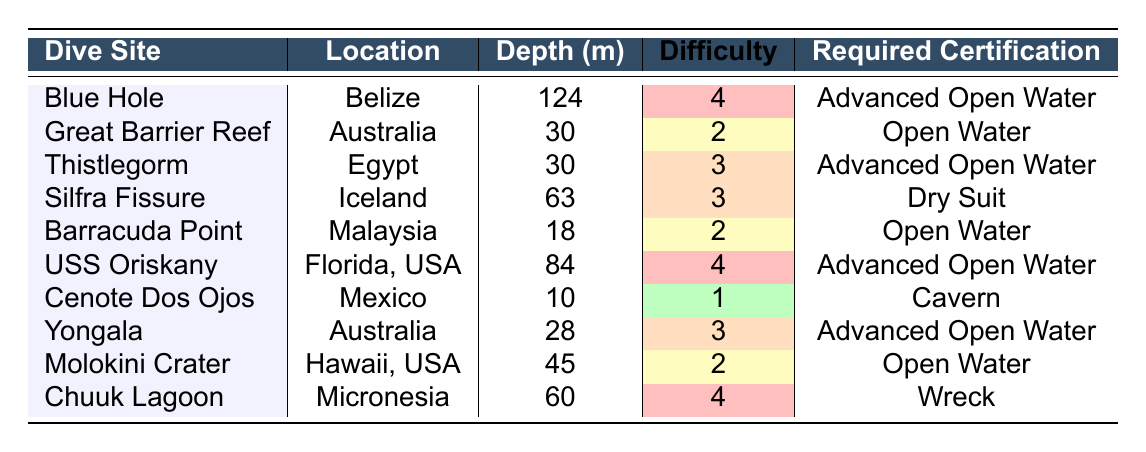What is the depth of the Blue Hole dive site? The table lists the depth for each dive site. For the Blue Hole, the depth is explicitly stated as 124 meters.
Answer: 124 meters How many dive sites require Advanced Open Water certification? By examining the required certifications column, I can count the instances of "Advanced Open Water". There are three sites listed: Blue Hole, Thistlegorm, and USS Oriskany, Yongala also requires the same certification, making a total of four.
Answer: 4 Which dive site has the highest difficulty rating? The difficulty ratings for all dive sites are provided. The maximum rating is 4, which is associated with Blue Hole, USS Oriskany, and Chuuk Lagoon. Since we are looking for the highest, it's Blue Hole.
Answer: Blue Hole What is the average depth of the dive sites listed? We need to sum the depths of all the dive sites: 124 + 30 + 30 + 63 + 18 + 84 + 10 + 28 + 45 + 60 =  460 meters. There are 10 sites, so the average depth is 460/10 = 46 meters.
Answer: 46 meters Is there a dive site that is suitable for beginners? A beginner-friendly dive site typically requires an Open Water certification. Looking at the table, both the Great Barrier Reef and Barracuda Point require Open Water certification. Thus, the answer is yes.
Answer: Yes Which dive site in the table is located in Australia and what is its depth? The table shows two dive sites located in Australia: Great Barrier Reef (depth 30 m) and Yongala (depth 28 m). Both depths are mentioned.
Answer: Great Barrier Reef (30 m), Yongala (28 m) What is the total depth of all dive sites that require a Dry Suit certification? The table indicates that only one dive site, Silfra Fissure, requires a Dry Suit certification with a depth of 63 meters. Therefore, the total is 63 meters.
Answer: 63 meters Are any dive sites located in the USA? The table lists USS Oriskany and Molokini Crater as dive sites in the USA, fulfilling the criteria of being located in the USA.
Answer: Yes Which dive site has a depth closest to the average depth of the listed sites? The average depth is 46 meters. From the table, Molokini Crater (45 meters) is closest as it is just 1 meter below the average.
Answer: Molokini Crater Which dive site requires the least advanced certification? The certification that requires the least amount of training is Cavern, which is required for Cenote Dos Ojos. This is the only dive site with this certification, which indicates it requires less advanced training.
Answer: Cenote Dos Ojos 